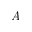Convert formula to latex. <formula><loc_0><loc_0><loc_500><loc_500>A</formula> 